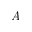Convert formula to latex. <formula><loc_0><loc_0><loc_500><loc_500>A</formula> 